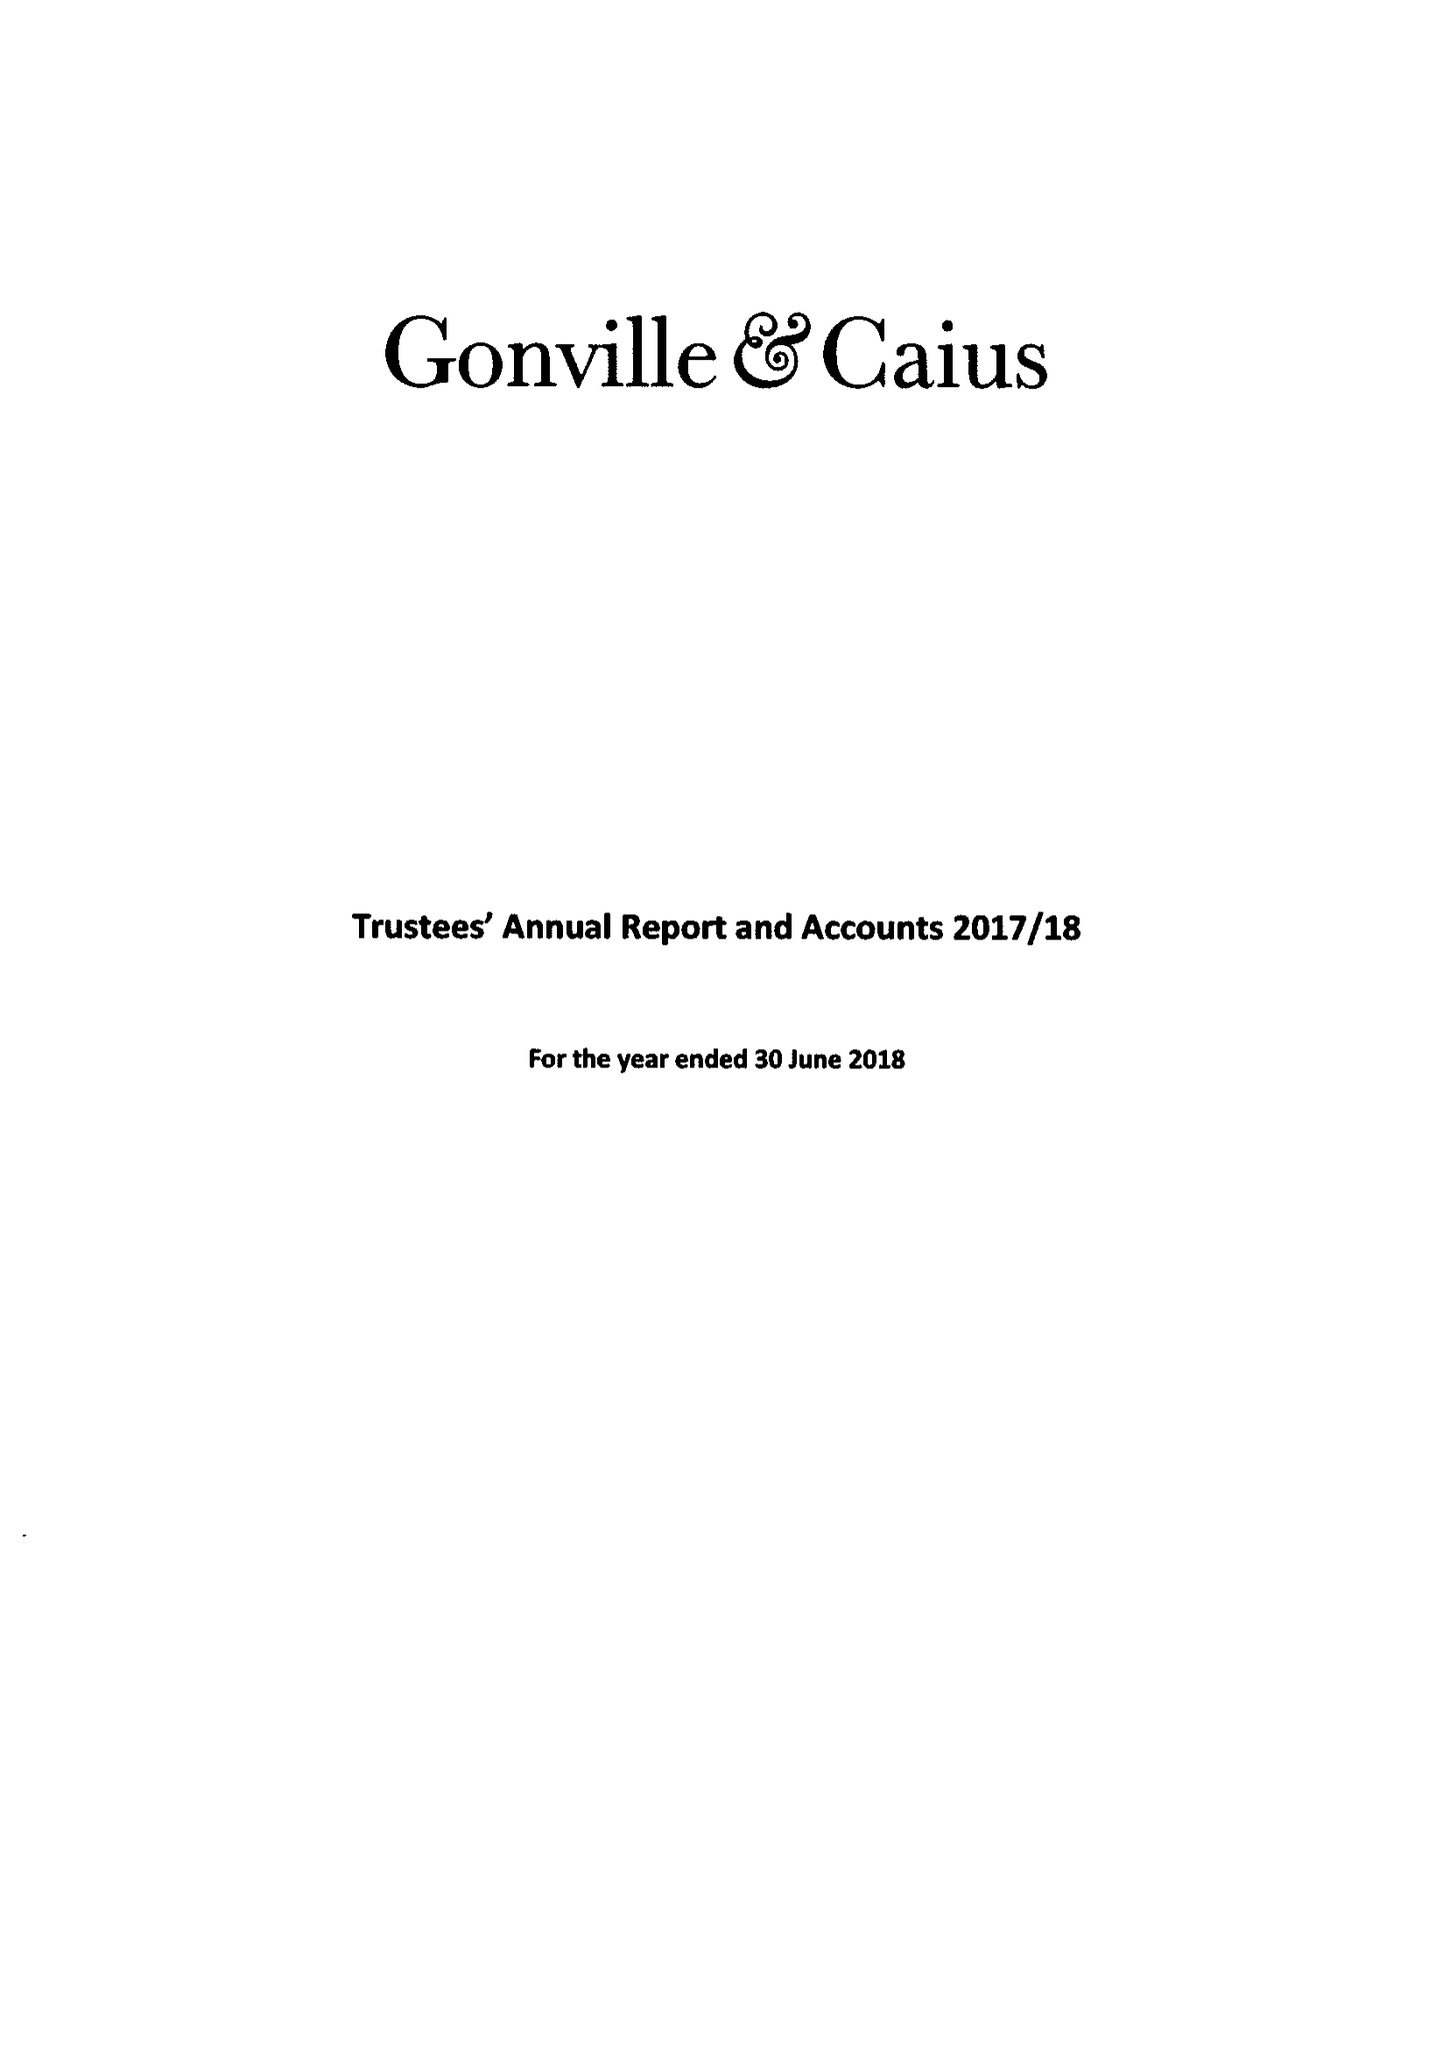What is the value for the income_annually_in_british_pounds?
Answer the question using a single word or phrase. 20761000.00 